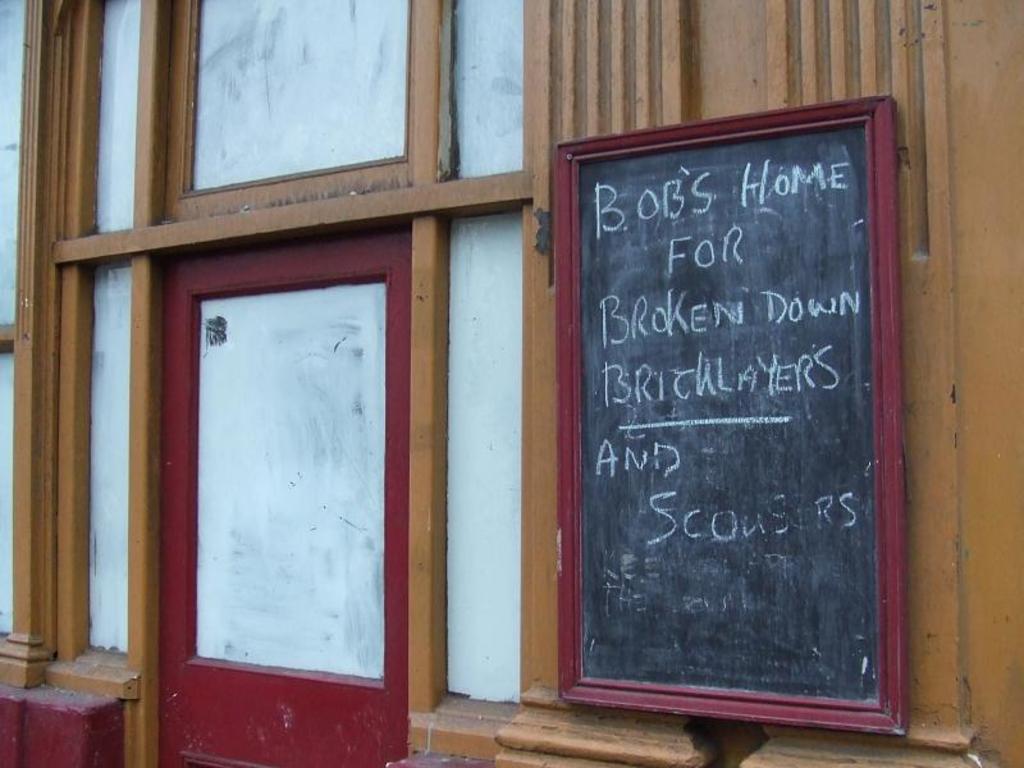How would you summarize this image in a sentence or two? In the picture I can see a black board on which we can see some text is written is fixed to the wall. Here we can see the brown, white and maroon color frame on the wall. 